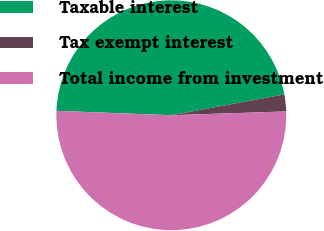Convert chart to OTSL. <chart><loc_0><loc_0><loc_500><loc_500><pie_chart><fcel>Taxable interest<fcel>Tax exempt interest<fcel>Total income from investment<nl><fcel>46.49%<fcel>2.37%<fcel>51.14%<nl></chart> 